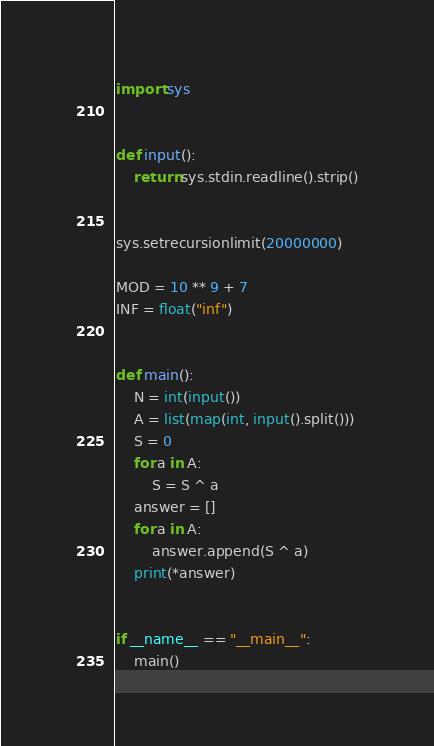Convert code to text. <code><loc_0><loc_0><loc_500><loc_500><_Python_>import sys


def input():
    return sys.stdin.readline().strip()


sys.setrecursionlimit(20000000)

MOD = 10 ** 9 + 7
INF = float("inf")


def main():
    N = int(input())
    A = list(map(int, input().split()))
    S = 0
    for a in A:
        S = S ^ a
    answer = []
    for a in A:
        answer.append(S ^ a)
    print(*answer)


if __name__ == "__main__":
    main()
</code> 